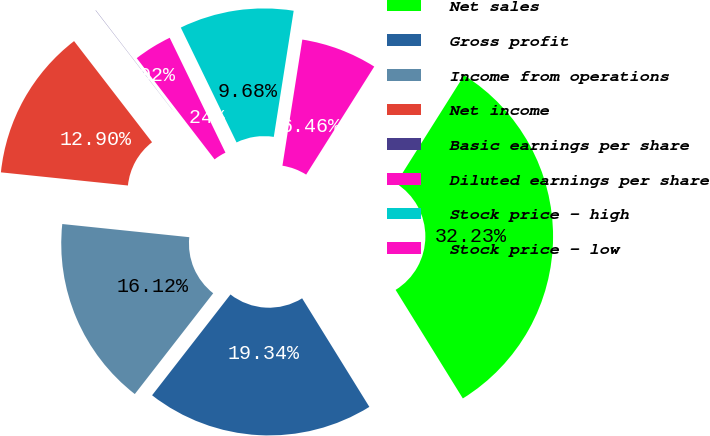<chart> <loc_0><loc_0><loc_500><loc_500><pie_chart><fcel>Net sales<fcel>Gross profit<fcel>Income from operations<fcel>Net income<fcel>Basic earnings per share<fcel>Diluted earnings per share<fcel>Stock price - high<fcel>Stock price - low<nl><fcel>32.22%<fcel>19.34%<fcel>16.12%<fcel>12.9%<fcel>0.02%<fcel>3.24%<fcel>9.68%<fcel>6.46%<nl></chart> 